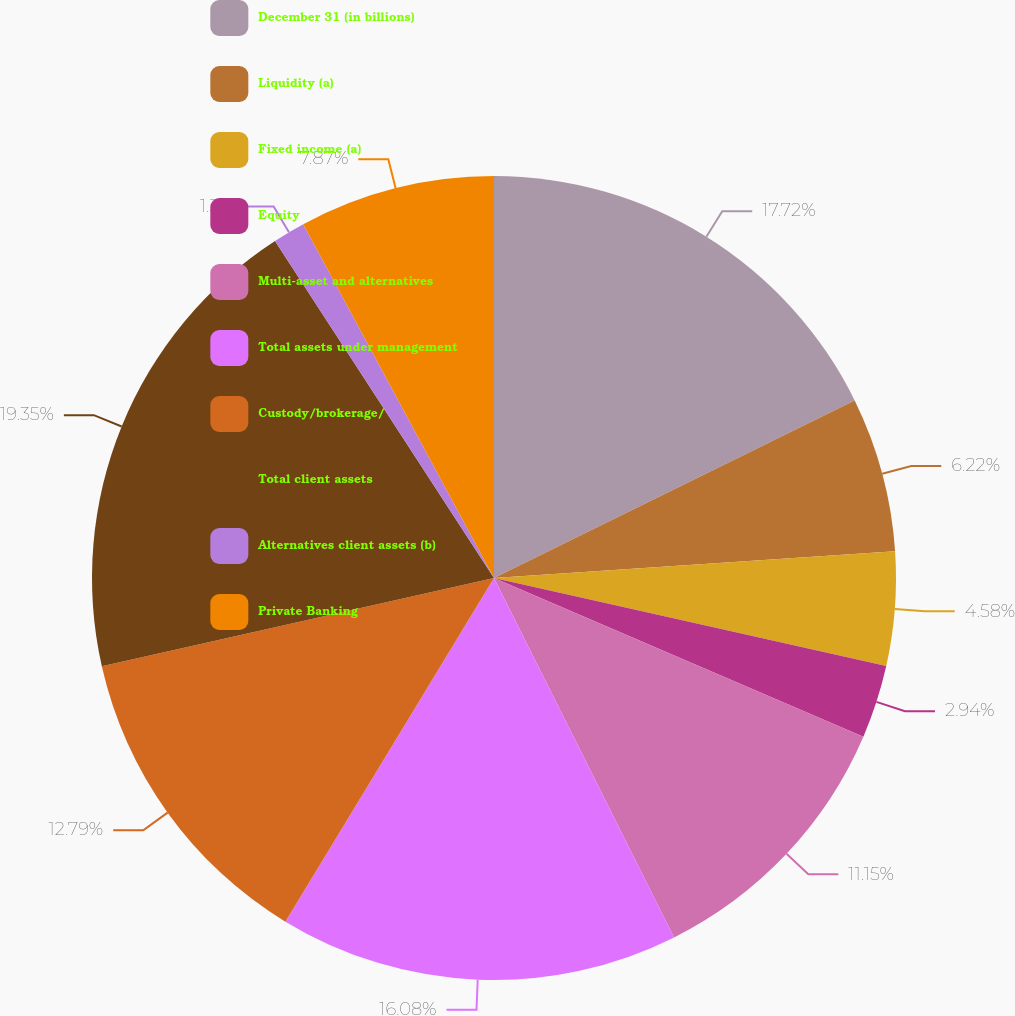Convert chart. <chart><loc_0><loc_0><loc_500><loc_500><pie_chart><fcel>December 31 (in billions)<fcel>Liquidity (a)<fcel>Fixed income (a)<fcel>Equity<fcel>Multi-asset and alternatives<fcel>Total assets under management<fcel>Custody/brokerage/<fcel>Total client assets<fcel>Alternatives client assets (b)<fcel>Private Banking<nl><fcel>17.72%<fcel>6.22%<fcel>4.58%<fcel>2.94%<fcel>11.15%<fcel>16.08%<fcel>12.79%<fcel>19.36%<fcel>1.3%<fcel>7.87%<nl></chart> 